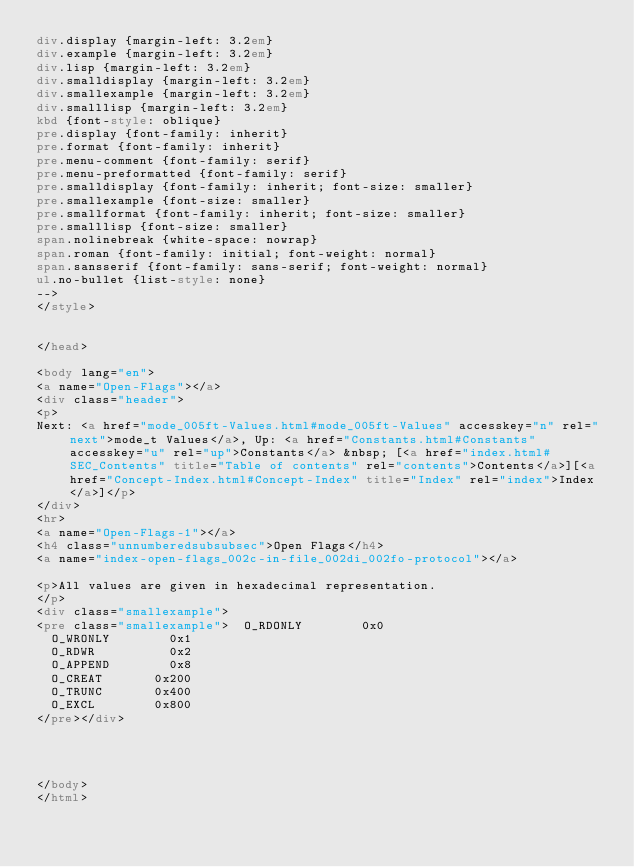<code> <loc_0><loc_0><loc_500><loc_500><_HTML_>div.display {margin-left: 3.2em}
div.example {margin-left: 3.2em}
div.lisp {margin-left: 3.2em}
div.smalldisplay {margin-left: 3.2em}
div.smallexample {margin-left: 3.2em}
div.smalllisp {margin-left: 3.2em}
kbd {font-style: oblique}
pre.display {font-family: inherit}
pre.format {font-family: inherit}
pre.menu-comment {font-family: serif}
pre.menu-preformatted {font-family: serif}
pre.smalldisplay {font-family: inherit; font-size: smaller}
pre.smallexample {font-size: smaller}
pre.smallformat {font-family: inherit; font-size: smaller}
pre.smalllisp {font-size: smaller}
span.nolinebreak {white-space: nowrap}
span.roman {font-family: initial; font-weight: normal}
span.sansserif {font-family: sans-serif; font-weight: normal}
ul.no-bullet {list-style: none}
-->
</style>


</head>

<body lang="en">
<a name="Open-Flags"></a>
<div class="header">
<p>
Next: <a href="mode_005ft-Values.html#mode_005ft-Values" accesskey="n" rel="next">mode_t Values</a>, Up: <a href="Constants.html#Constants" accesskey="u" rel="up">Constants</a> &nbsp; [<a href="index.html#SEC_Contents" title="Table of contents" rel="contents">Contents</a>][<a href="Concept-Index.html#Concept-Index" title="Index" rel="index">Index</a>]</p>
</div>
<hr>
<a name="Open-Flags-1"></a>
<h4 class="unnumberedsubsubsec">Open Flags</h4>
<a name="index-open-flags_002c-in-file_002di_002fo-protocol"></a>

<p>All values are given in hexadecimal representation.
</p>
<div class="smallexample">
<pre class="smallexample">  O_RDONLY        0x0
  O_WRONLY        0x1
  O_RDWR          0x2
  O_APPEND        0x8
  O_CREAT       0x200
  O_TRUNC       0x400
  O_EXCL        0x800
</pre></div>




</body>
</html>
</code> 